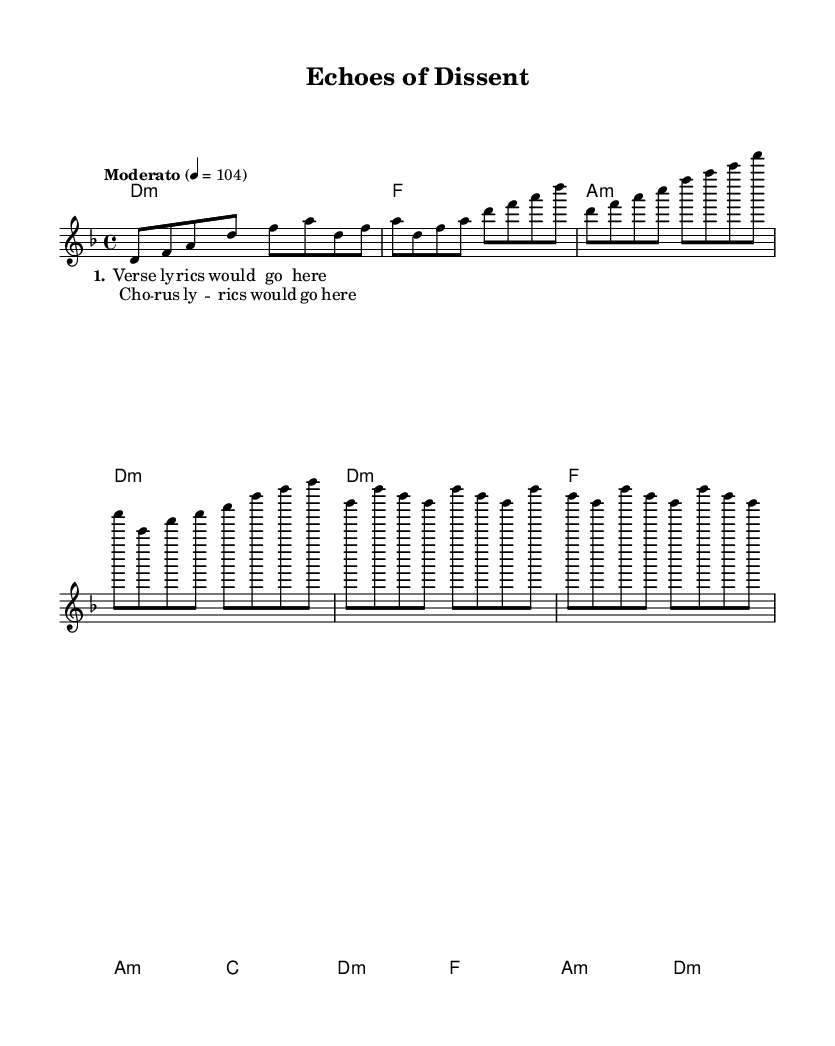What is the key signature of this music? The key signature indicated is D minor, which has one flat (B flat).
Answer: D minor What is the time signature of this piece? The time signature of the piece is 4/4, meaning there are four beats per measure and a quarter note receives one beat.
Answer: 4/4 What is the tempo marking for the piece? The tempo marking indicates "Moderato," with a tempo of 104 beats per minute, suggesting a moderate speed suited for a protest song.
Answer: Moderato How many measures are in the verse section? The verse section features four measures, as identified by the melody and harmony arrangement provided.
Answer: 4 What is the relationship of the chorus to the verse in terms of chords? The chorus uses the same chord structure as the verse, namely D minor, F major, A minor, and D minor, indicating a consistent harmonic foundation throughout the song.
Answer: Same chords What type of lyrics does the title suggest for this song? The title "Echoes of Dissent" implies politically charged lyrics, likely addressing themes of resistance or protest relating to the Vietnam War era.
Answer: Politically charged What distinguishes this song as a protest song from the Vietnam War era? This song is characterized by its use of hard-hitting themes and melodies that resonate with the emotional struggles and controversies surrounding the Vietnam War, making it an anthem of societal dissent.
Answer: Hard-hitting themes 